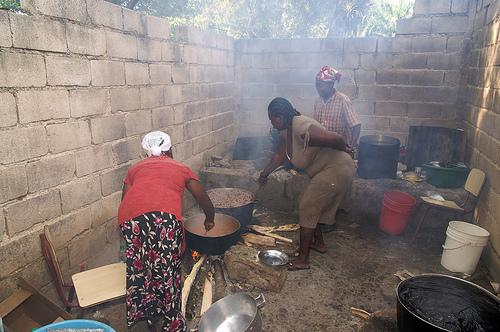Question: what are the women doing?
Choices:
A. Cleaning.
B. Reading.
C. Cooking.
D. Writing.
Answer with the letter. Answer: C Question: how many women are in the picture?
Choices:
A. Four.
B. Five.
C. Six.
D. Three.
Answer with the letter. Answer: D Question: what are the women cooking in?
Choices:
A. Pans.
B. Bowls.
C. Pots.
D. Dishes.
Answer with the letter. Answer: C Question: why is there smoke in the picture?
Choices:
A. Someone is smoking a cigarette.
B. Someone lit incense.
C. From the cooking fire.
D. The house is on fire.
Answer with the letter. Answer: C Question: what material is the open building made from?
Choices:
A. Bricks.
B. Limestone.
C. Marble.
D. Cement blocks.
Answer with the letter. Answer: D Question: why does the building have no roof?
Choices:
A. Because a tornado blew it off.
B. Because they took it off to put on a new one.
C. Because it's a new type of house that doesn't need a roof.
D. So the smoke can escape.
Answer with the letter. Answer: D Question: what design does the woman in front have on her skirt?
Choices:
A. A polka dot design.
B. A checkered design.
C. A plain design.
D. A floral design.
Answer with the letter. Answer: D 